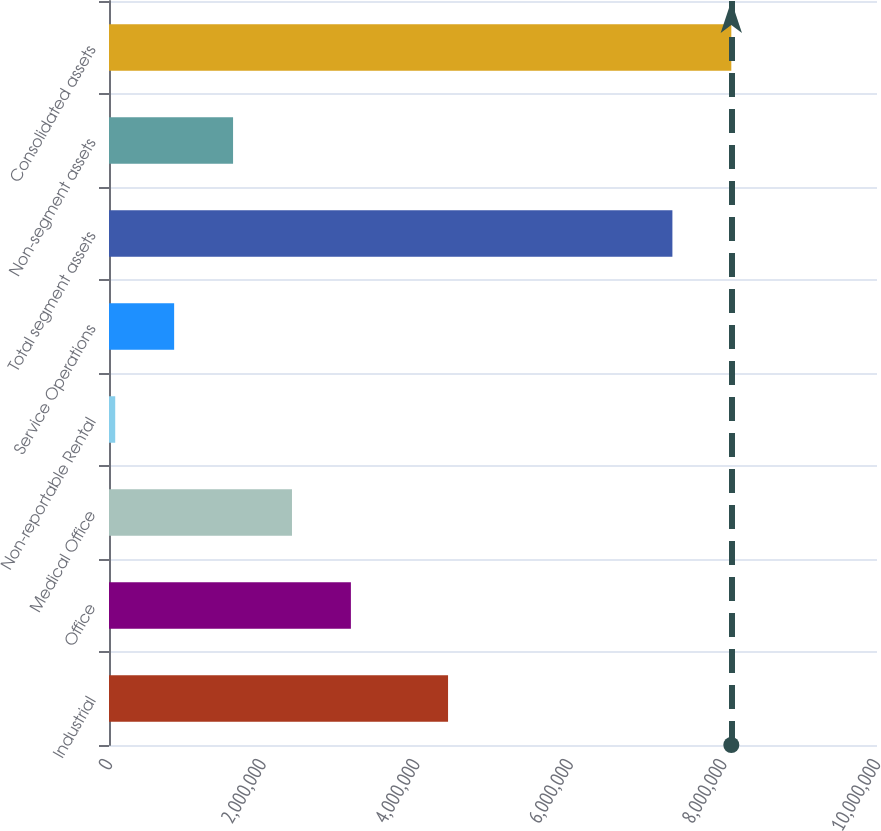<chart> <loc_0><loc_0><loc_500><loc_500><bar_chart><fcel>Industrial<fcel>Office<fcel>Medical Office<fcel>Non-reportable Rental<fcel>Service Operations<fcel>Total segment assets<fcel>Non-segment assets<fcel>Consolidated assets<nl><fcel>4.41474e+06<fcel>3.14968e+06<fcel>2.38252e+06<fcel>81056<fcel>848212<fcel>7.33594e+06<fcel>1.61537e+06<fcel>8.10309e+06<nl></chart> 